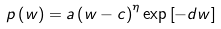Convert formula to latex. <formula><loc_0><loc_0><loc_500><loc_500>p \left ( w \right ) = a \left ( w - c \right ) ^ { \eta } \exp \left [ - d w \right ]</formula> 